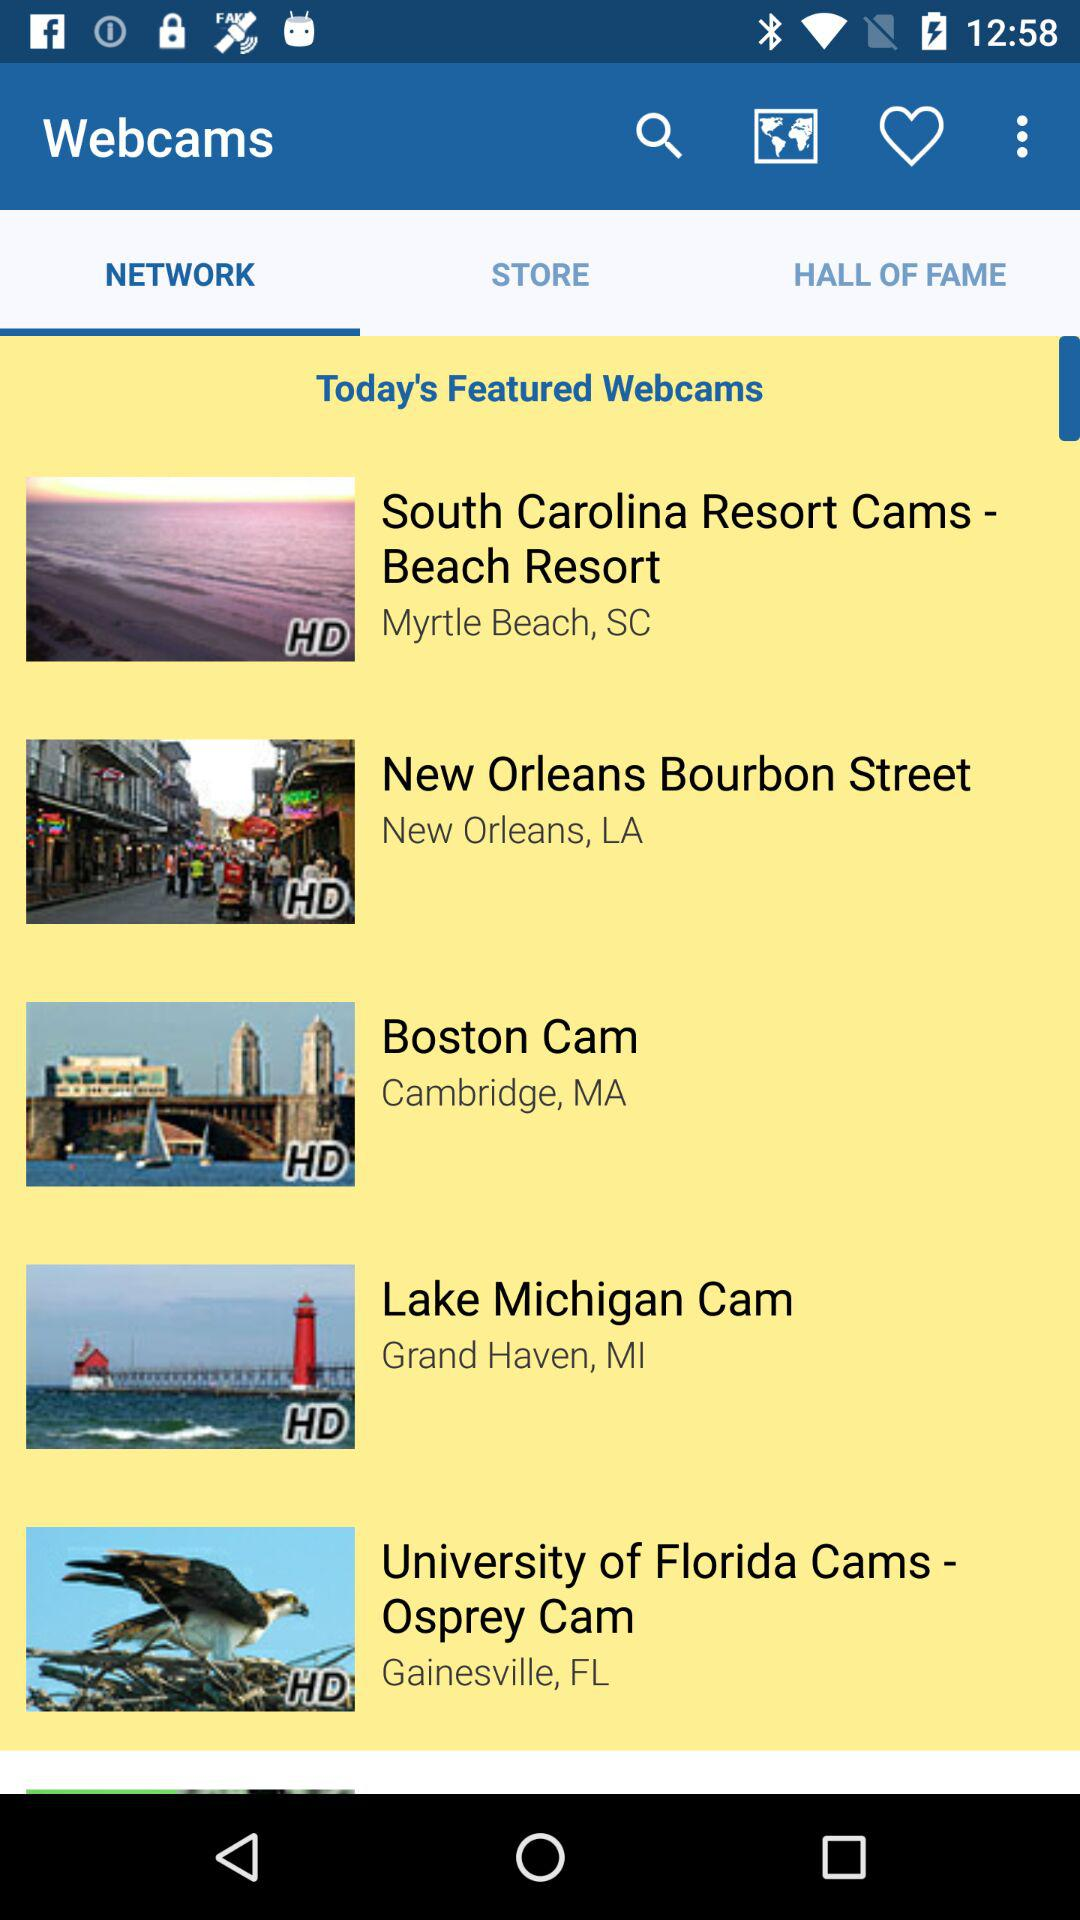What is the location of "Boston Cam"? The location of "Boston Cam" is Cambridge, MA. 